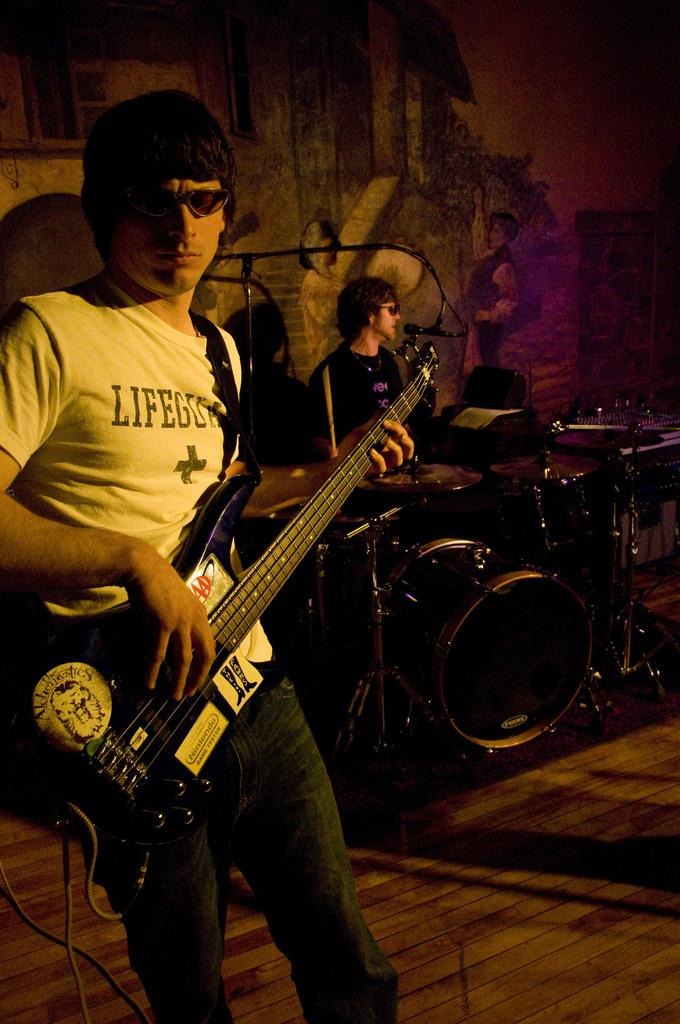How many people are in the image? There are two people in the image. What is the man on the left side of the image doing? The man on the left side of the image is playing a guitar. What is the man in the middle of the image doing? The man in the middle of the image is playing drums. What is the man playing drums standing in front of? The man playing drums is in front of a microphone. Where is the arch located in the image? There is no arch present in the image. What type of toy is the ladybug playing with in the image? There is no ladybug or toy present in the image. 